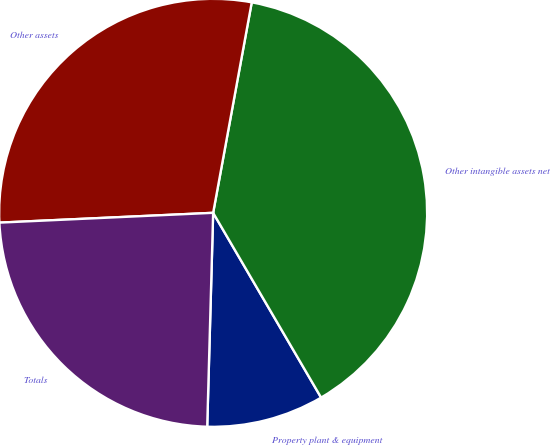Convert chart. <chart><loc_0><loc_0><loc_500><loc_500><pie_chart><fcel>Property plant & equipment<fcel>Other intangible assets net<fcel>Other assets<fcel>Totals<nl><fcel>8.86%<fcel>38.7%<fcel>28.62%<fcel>23.83%<nl></chart> 